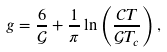<formula> <loc_0><loc_0><loc_500><loc_500>g = \frac { 6 } { \mathcal { G } } + \frac { 1 } { \pi } \ln \left ( \frac { \mathcal { C } T } { \mathcal { G } T _ { c } } \right ) ,</formula> 